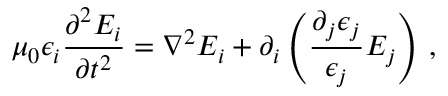<formula> <loc_0><loc_0><loc_500><loc_500>\mu _ { 0 } \epsilon _ { i } \frac { \partial ^ { 2 } E _ { i } } { \partial t ^ { 2 } } = \nabla ^ { 2 } E _ { i } + \partial _ { i } \left ( \frac { \partial _ { j } \epsilon _ { j } } { \epsilon _ { j } } E _ { j } \right ) \, ,</formula> 